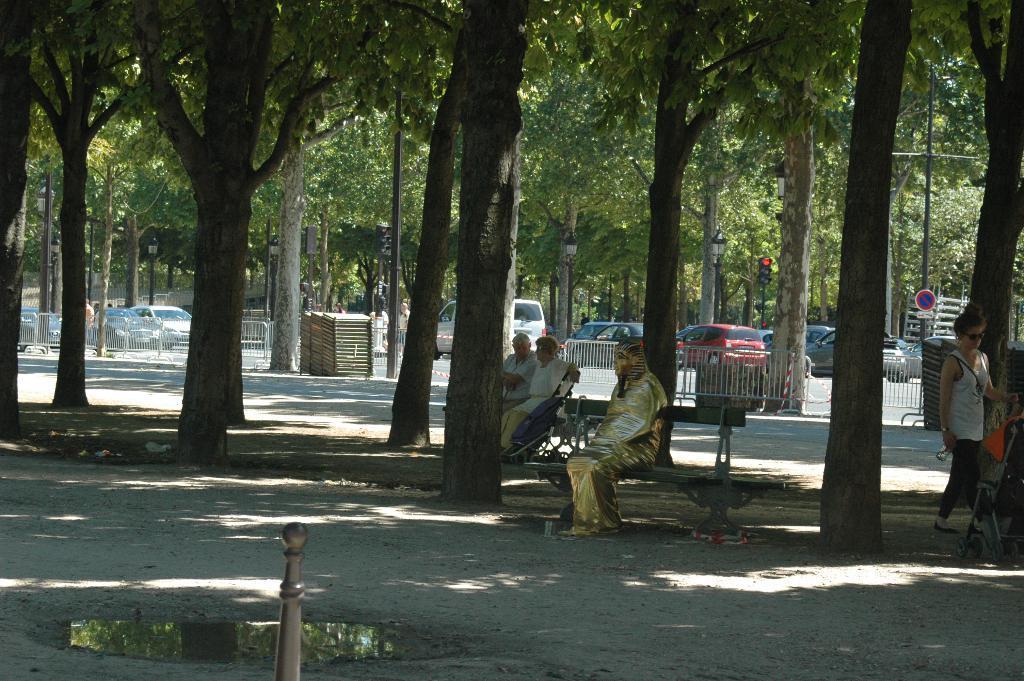In one or two sentences, can you explain what this image depicts? In this image I can see a statue which is god in color is sitting on a bench, few persons sitting and few persons standing on the ground. I can see few trees and few vehicles on the road. In the background I can see few trees, a traffic signal, few moles, a sign board and the white colored railing. 